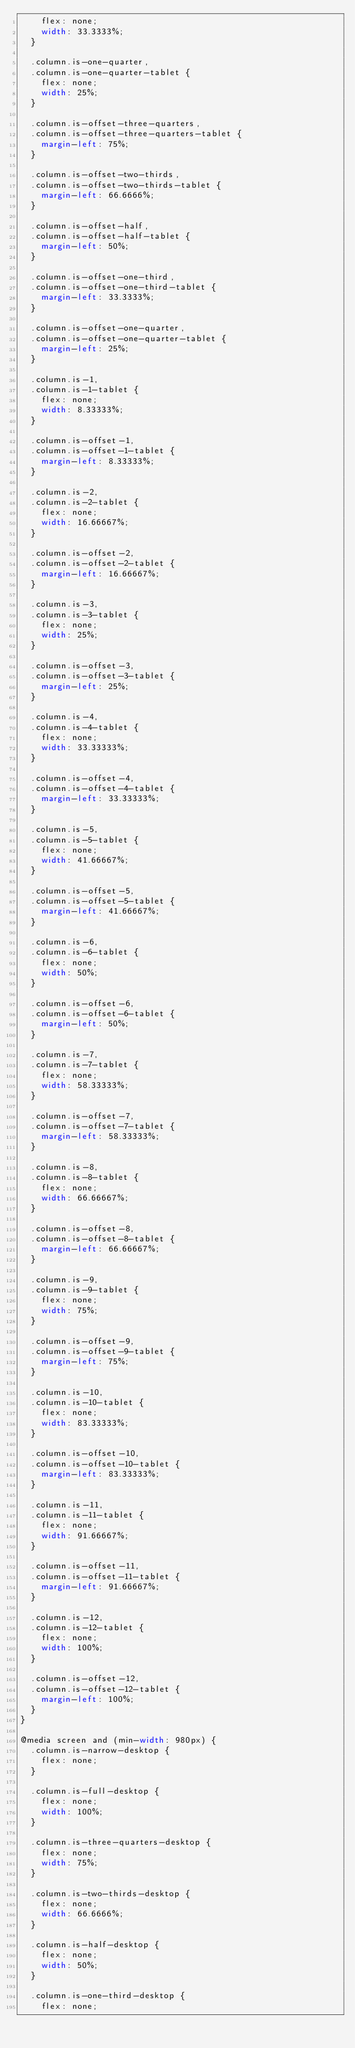<code> <loc_0><loc_0><loc_500><loc_500><_CSS_>    flex: none;
    width: 33.3333%;
  }

  .column.is-one-quarter,
  .column.is-one-quarter-tablet {
    flex: none;
    width: 25%;
  }

  .column.is-offset-three-quarters,
  .column.is-offset-three-quarters-tablet {
    margin-left: 75%;
  }

  .column.is-offset-two-thirds,
  .column.is-offset-two-thirds-tablet {
    margin-left: 66.6666%;
  }

  .column.is-offset-half,
  .column.is-offset-half-tablet {
    margin-left: 50%;
  }

  .column.is-offset-one-third,
  .column.is-offset-one-third-tablet {
    margin-left: 33.3333%;
  }

  .column.is-offset-one-quarter,
  .column.is-offset-one-quarter-tablet {
    margin-left: 25%;
  }

  .column.is-1,
  .column.is-1-tablet {
    flex: none;
    width: 8.33333%;
  }

  .column.is-offset-1,
  .column.is-offset-1-tablet {
    margin-left: 8.33333%;
  }

  .column.is-2,
  .column.is-2-tablet {
    flex: none;
    width: 16.66667%;
  }

  .column.is-offset-2,
  .column.is-offset-2-tablet {
    margin-left: 16.66667%;
  }

  .column.is-3,
  .column.is-3-tablet {
    flex: none;
    width: 25%;
  }

  .column.is-offset-3,
  .column.is-offset-3-tablet {
    margin-left: 25%;
  }

  .column.is-4,
  .column.is-4-tablet {
    flex: none;
    width: 33.33333%;
  }

  .column.is-offset-4,
  .column.is-offset-4-tablet {
    margin-left: 33.33333%;
  }

  .column.is-5,
  .column.is-5-tablet {
    flex: none;
    width: 41.66667%;
  }

  .column.is-offset-5,
  .column.is-offset-5-tablet {
    margin-left: 41.66667%;
  }

  .column.is-6,
  .column.is-6-tablet {
    flex: none;
    width: 50%;
  }

  .column.is-offset-6,
  .column.is-offset-6-tablet {
    margin-left: 50%;
  }

  .column.is-7,
  .column.is-7-tablet {
    flex: none;
    width: 58.33333%;
  }

  .column.is-offset-7,
  .column.is-offset-7-tablet {
    margin-left: 58.33333%;
  }

  .column.is-8,
  .column.is-8-tablet {
    flex: none;
    width: 66.66667%;
  }

  .column.is-offset-8,
  .column.is-offset-8-tablet {
    margin-left: 66.66667%;
  }

  .column.is-9,
  .column.is-9-tablet {
    flex: none;
    width: 75%;
  }

  .column.is-offset-9,
  .column.is-offset-9-tablet {
    margin-left: 75%;
  }

  .column.is-10,
  .column.is-10-tablet {
    flex: none;
    width: 83.33333%;
  }

  .column.is-offset-10,
  .column.is-offset-10-tablet {
    margin-left: 83.33333%;
  }

  .column.is-11,
  .column.is-11-tablet {
    flex: none;
    width: 91.66667%;
  }

  .column.is-offset-11,
  .column.is-offset-11-tablet {
    margin-left: 91.66667%;
  }

  .column.is-12,
  .column.is-12-tablet {
    flex: none;
    width: 100%;
  }

  .column.is-offset-12,
  .column.is-offset-12-tablet {
    margin-left: 100%;
  }
}

@media screen and (min-width: 980px) {
  .column.is-narrow-desktop {
    flex: none;
  }

  .column.is-full-desktop {
    flex: none;
    width: 100%;
  }

  .column.is-three-quarters-desktop {
    flex: none;
    width: 75%;
  }

  .column.is-two-thirds-desktop {
    flex: none;
    width: 66.6666%;
  }

  .column.is-half-desktop {
    flex: none;
    width: 50%;
  }

  .column.is-one-third-desktop {
    flex: none;</code> 